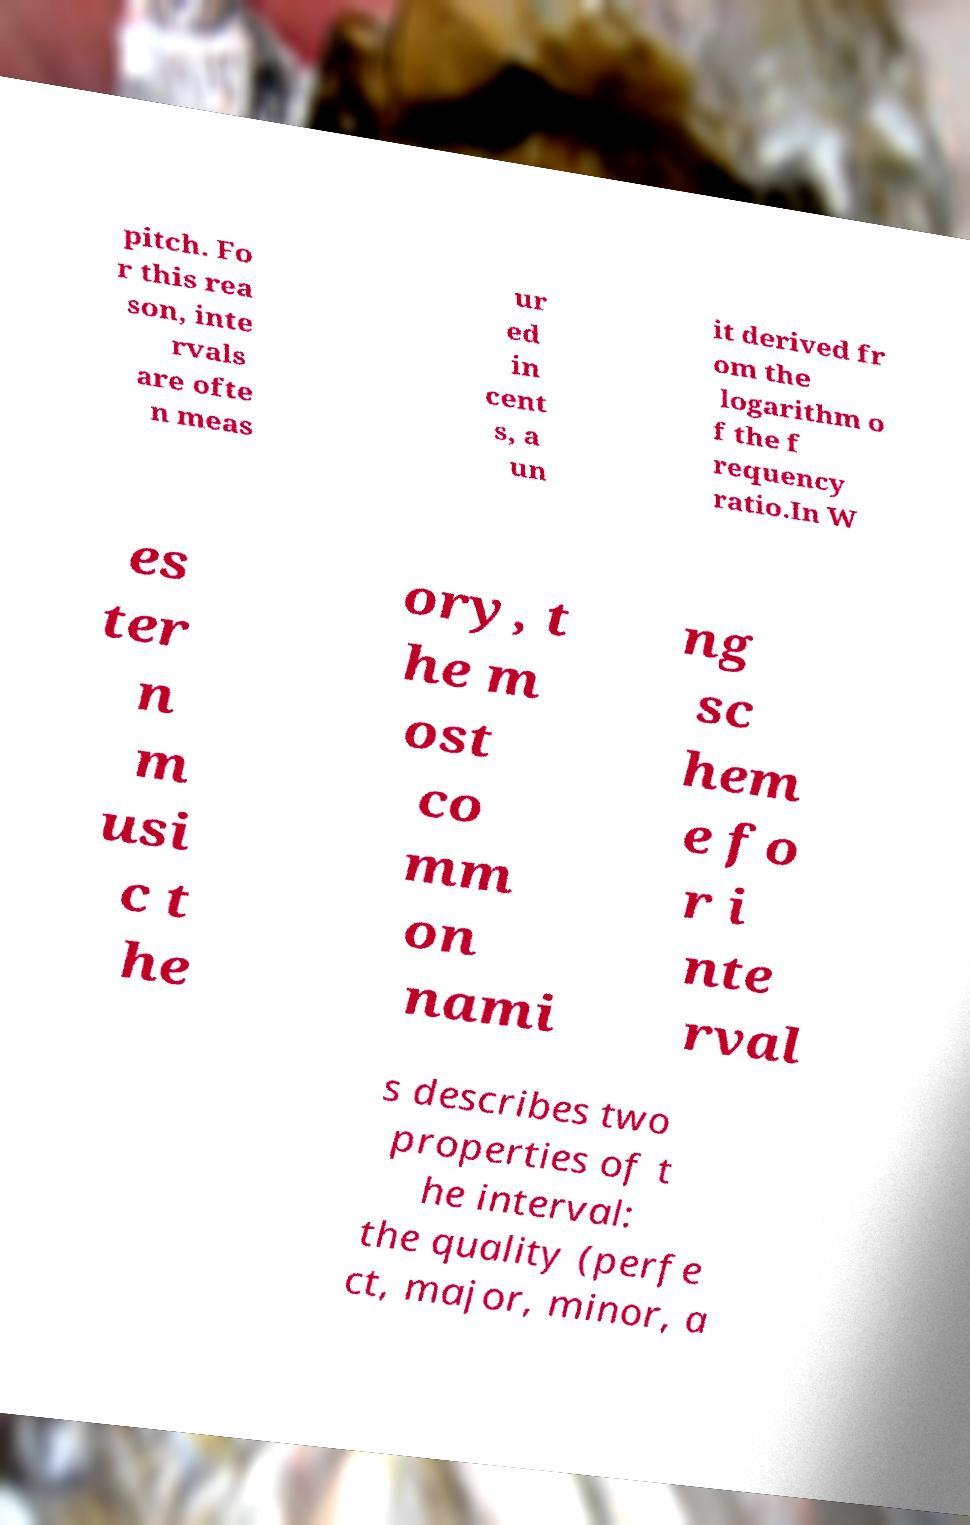For documentation purposes, I need the text within this image transcribed. Could you provide that? pitch. Fo r this rea son, inte rvals are ofte n meas ur ed in cent s, a un it derived fr om the logarithm o f the f requency ratio.In W es ter n m usi c t he ory, t he m ost co mm on nami ng sc hem e fo r i nte rval s describes two properties of t he interval: the quality (perfe ct, major, minor, a 